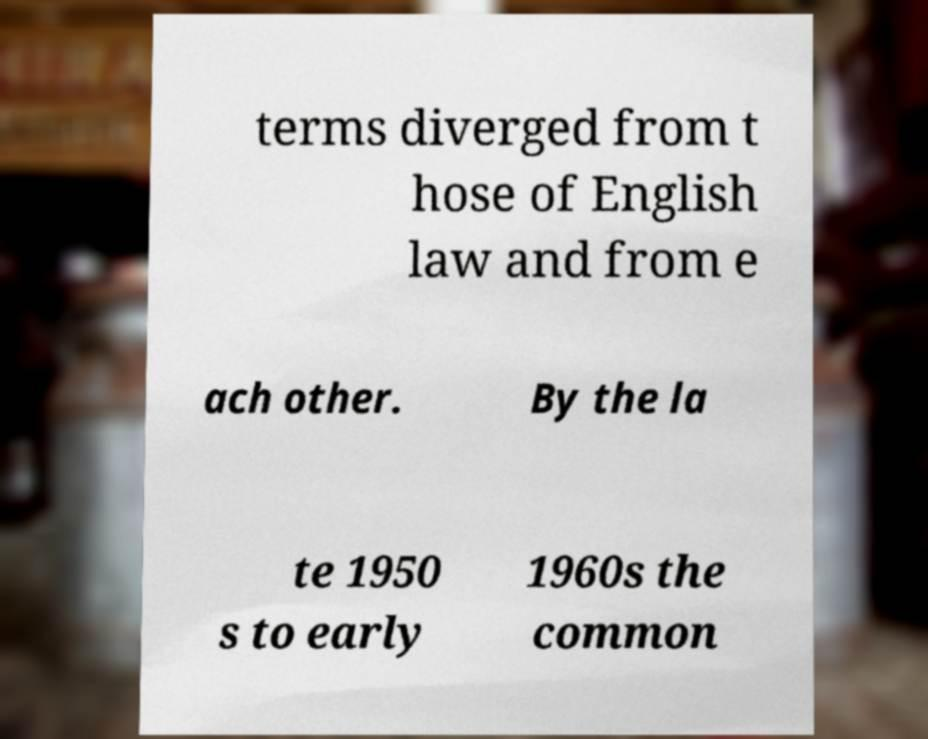For documentation purposes, I need the text within this image transcribed. Could you provide that? terms diverged from t hose of English law and from e ach other. By the la te 1950 s to early 1960s the common 